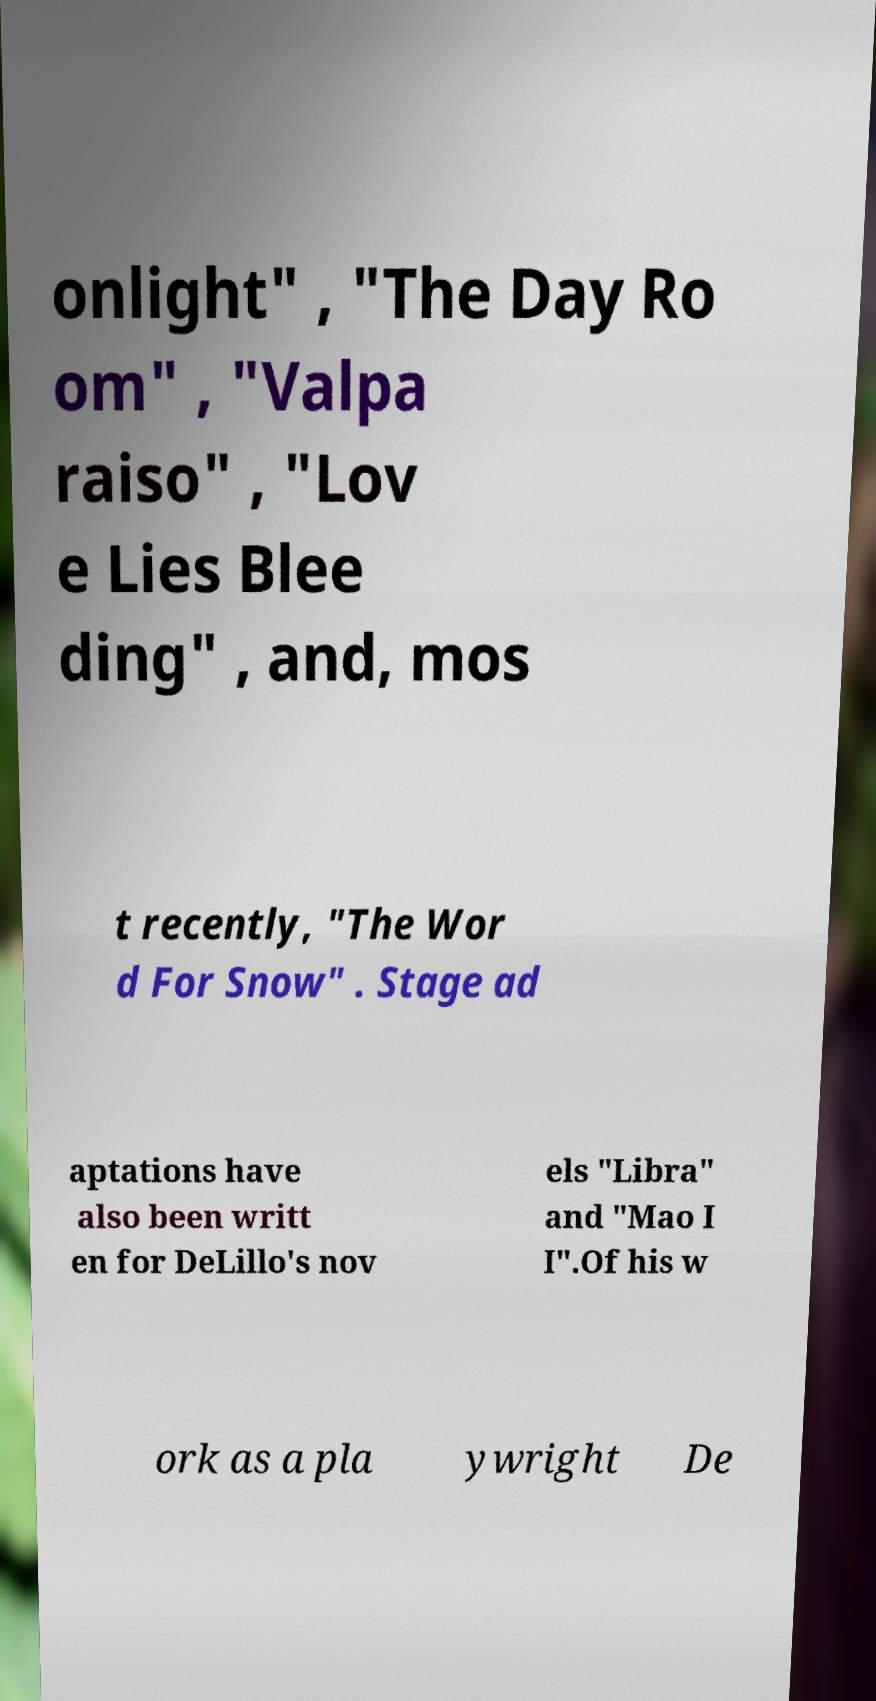Please identify and transcribe the text found in this image. onlight" , "The Day Ro om" , "Valpa raiso" , "Lov e Lies Blee ding" , and, mos t recently, "The Wor d For Snow" . Stage ad aptations have also been writt en for DeLillo's nov els "Libra" and "Mao I I".Of his w ork as a pla ywright De 